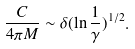Convert formula to latex. <formula><loc_0><loc_0><loc_500><loc_500>\frac { C } { 4 \pi M } \sim \delta ( \ln \frac { 1 } { \gamma } ) ^ { 1 / 2 } .</formula> 